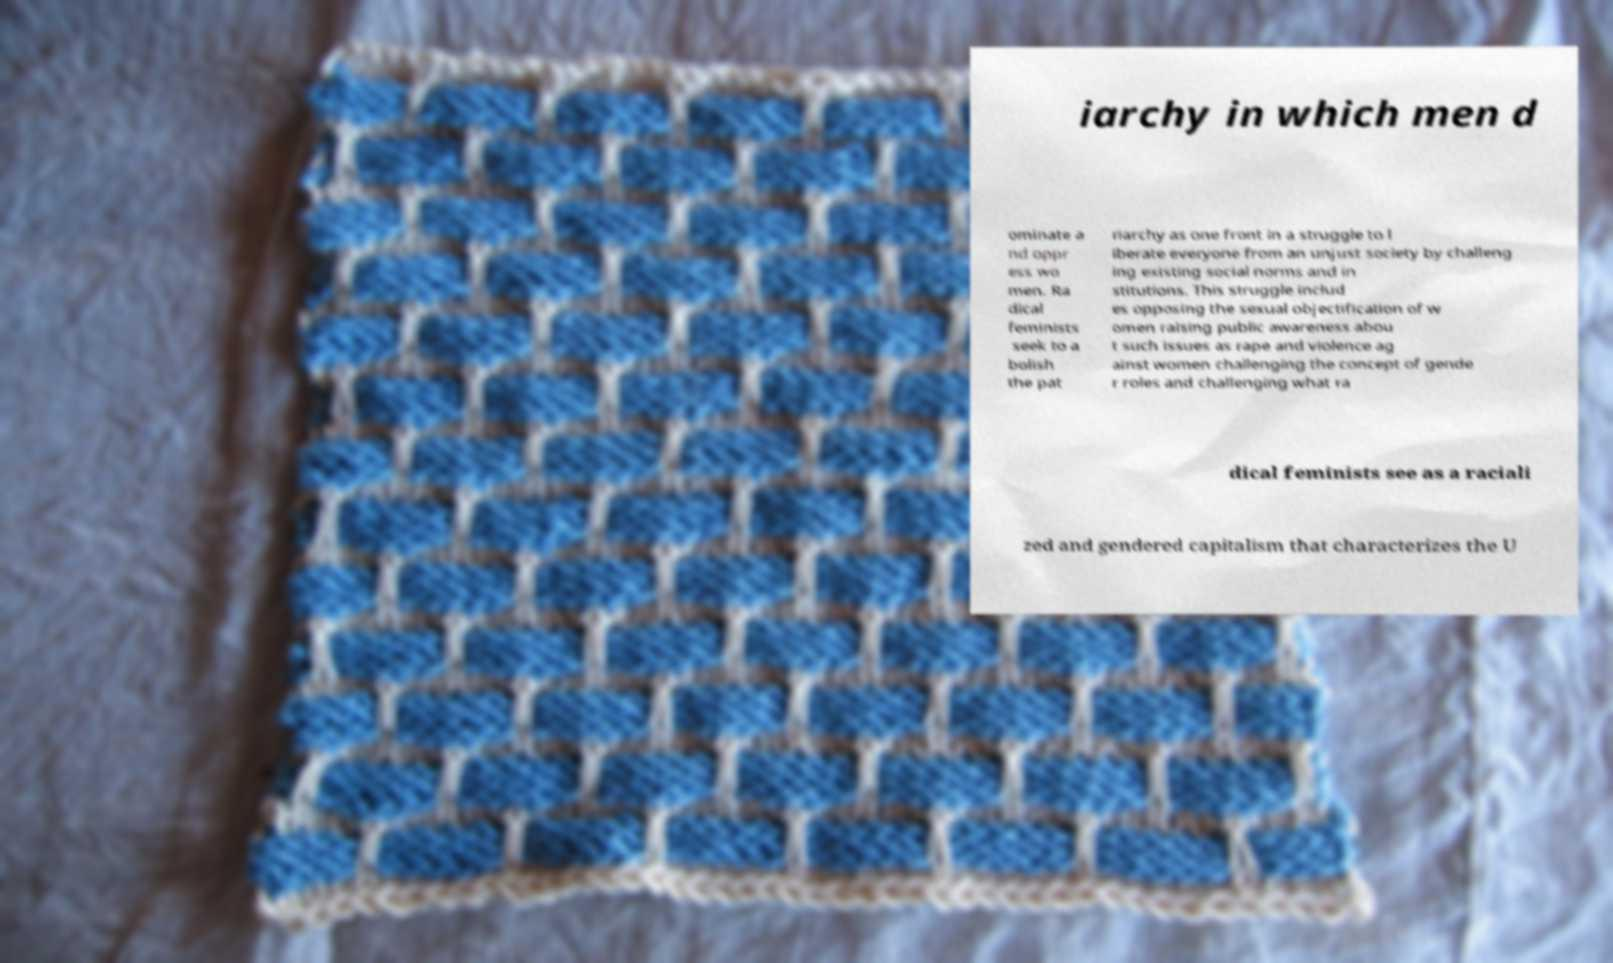Can you accurately transcribe the text from the provided image for me? iarchy in which men d ominate a nd oppr ess wo men. Ra dical feminists seek to a bolish the pat riarchy as one front in a struggle to l iberate everyone from an unjust society by challeng ing existing social norms and in stitutions. This struggle includ es opposing the sexual objectification of w omen raising public awareness abou t such issues as rape and violence ag ainst women challenging the concept of gende r roles and challenging what ra dical feminists see as a raciali zed and gendered capitalism that characterizes the U 